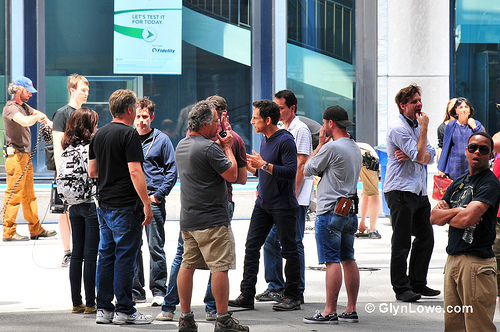<image>
Can you confirm if the man is to the left of the other man? Yes. From this viewpoint, the man is positioned to the left side relative to the other man. 